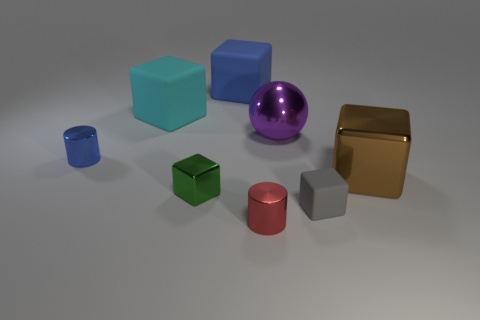How big is the blue object that is in front of the large blue cube?
Your answer should be very brief. Small. Is there a gray cube on the right side of the big purple ball that is behind the blue cylinder?
Your answer should be very brief. Yes. Are the blue thing that is behind the blue metal object and the gray thing made of the same material?
Provide a short and direct response. Yes. What number of large objects are to the left of the tiny gray rubber cube and on the right side of the tiny red object?
Your response must be concise. 1. What number of cyan things have the same material as the big purple ball?
Provide a short and direct response. 0. The large sphere that is the same material as the red thing is what color?
Keep it short and to the point. Purple. Is the number of tiny blue matte blocks less than the number of gray matte cubes?
Give a very brief answer. Yes. There is a cylinder that is in front of the gray matte cube in front of the cylinder to the left of the tiny red metallic cylinder; what is it made of?
Your answer should be very brief. Metal. What is the material of the tiny red thing?
Provide a succinct answer. Metal. There is a small block on the left side of the blue matte object; does it have the same color as the large object in front of the large sphere?
Your response must be concise. No. 